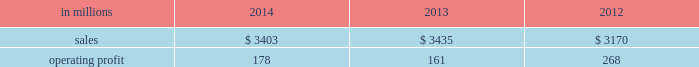Russia and europe .
Average sales price realizations for uncoated freesheet paper decreased in both europe and russia , reflecting weak economic conditions and soft market demand .
In russia , sales prices in rubles increased , but this improvement is masked by the impact of the currency depreciation against the u.s .
Dollar .
Input costs were significantly higher for wood in both europe and russia , partially offset by lower chemical costs .
Planned maintenance downtime costs were $ 11 million lower in 2014 than in 2013 .
Manufacturing and other operating costs were favorable .
Entering 2015 , sales volumes in the first quarter are expected to be seasonally weaker in russia , and about flat in europe .
Average sales price realizations for uncoated freesheet paper are expected to remain steady in europe , but increase in russia .
Input costs should be lower for oil and wood , partially offset by higher chemicals costs .
Indian papers net sales were $ 178 million in 2014 , $ 185 million ( $ 174 million excluding excise duties which were included in net sales in 2013 and prior periods ) in 2013 and $ 185 million ( $ 178 million excluding excise duties ) in 2012 .
Operating profits were $ 8 million ( a loss of $ 12 million excluding a gain related to the resolution of a legal contingency ) in 2014 , a loss of $ 145 million ( a loss of $ 22 million excluding goodwill and trade name impairment charges ) in 2013 and a loss of $ 16 million in 2012 .
Average sales price realizations improved in 2014 compared with 2013 due to the impact of price increases implemented in 2013 .
Sales volumes were flat , reflecting weak economic conditions .
Input costs were higher , primarily for wood .
Operating costs and planned maintenance downtime costs were lower in 2014 .
Looking ahead to the first quarter of 2015 , sales volumes are expected to be seasonally higher .
Average sales price realizations are expected to decrease due to competitive pressures .
Asian printing papers net sales were $ 59 million in 2014 , $ 90 million in 2013 and $ 85 million in 2012 .
Operating profits were $ 0 million in 2014 and $ 1 million in both 2013 and 2012 .
U.s .
Pulp net sales were $ 895 million in 2014 compared with $ 815 million in 2013 and $ 725 million in 2012 .
Operating profits were $ 57 million in 2014 compared with $ 2 million in 2013 and a loss of $ 59 million in 2012 .
Sales volumes in 2014 increased from 2013 for both fluff pulp and market pulp reflecting improved market demand .
Average sales price realizations increased significantly for fluff pulp , while prices for market pulp were also higher .
Input costs for wood and energy were higher .
Operating costs were lower , but planned maintenance downtime costs were $ 1 million higher .
Compared with the fourth quarter of 2014 , sales volumes in the first quarter of 2015 , are expected to decrease for market pulp , but be slightly higher for fluff pulp .
Average sales price realizations are expected to to be stable for fluff pulp and softwood market pulp , while hardwood market pulp prices are expected to improve .
Input costs should be flat .
Planned maintenance downtime costs should be about $ 13 million higher than in the fourth quarter of 2014 .
Consumer packaging demand and pricing for consumer packaging products correlate closely with consumer spending and general economic activity .
In addition to prices and volumes , major factors affecting the profitability of consumer packaging are raw material and energy costs , freight costs , manufacturing efficiency and product mix .
Consumer packaging net sales in 2014 decreased 1% ( 1 % ) from 2013 , but increased 7% ( 7 % ) from 2012 .
Operating profits increased 11% ( 11 % ) from 2013 , but decreased 34% ( 34 % ) from 2012 .
Excluding sheet plant closure costs , costs associated with the permanent shutdown of a paper machine at our augusta , georgia mill and costs related to the sale of the shorewood business , 2014 operating profits were 11% ( 11 % ) lower than in 2013 , and 30% ( 30 % ) lower than in 2012 .
Benefits from higher average sales price realizations and a favorable mix ( $ 60 million ) were offset by lower sales volumes ( $ 11 million ) , higher operating costs ( $ 9 million ) , higher planned maintenance downtime costs ( $ 12 million ) , higher input costs ( $ 43 million ) and higher other costs ( $ 7 million ) .
In addition , operating profits in 2014 include $ 8 million of costs associated with sheet plant closures , while operating profits in 2013 include costs of $ 45 million related to the permanent shutdown of a paper machine at our augusta , georgia mill and $ 2 million of costs associated with the sale of the shorewood business .
Consumer packaging .
North american consumer packaging net sales were $ 2.0 billion in 2014 compared with $ 2.0 billion in 2013 and $ 2.0 billion in 2012 .
Operating profits were $ 92 million ( $ 100 million excluding sheet plant closure costs ) in 2014 compared with $ 63 million ( $ 110 million excluding paper machine shutdown costs and costs related to the sale of the shorewood business ) in 2013 and $ 165 million ( $ 162 million excluding a gain associated with the sale of the shorewood business in 2012 ) .
Coated paperboard sales volumes in 2014 were lower than in 2013 reflecting weaker market demand .
The business took about 41000 tons of market-related downtime in 2014 compared with about 24000 tons in 2013 .
Average sales price realizations increased year- .
What percentage where north american consumer packaging net sales of consumer packaging sales in 2013? 
Computations: ((2 * 1000) / 3435)
Answer: 0.58224. 